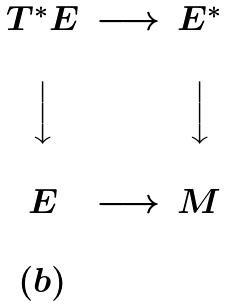Convert formula to latex. <formula><loc_0><loc_0><loc_500><loc_500>\begin{matrix} & & & \\ & T ^ { * } E & \longrightarrow & E ^ { * } \\ & & & \\ & \Big \downarrow & & \Big \downarrow \\ & & & \\ & E & \longrightarrow & M \\ & & & \\ & ( b ) & & \\ \end{matrix}</formula> 